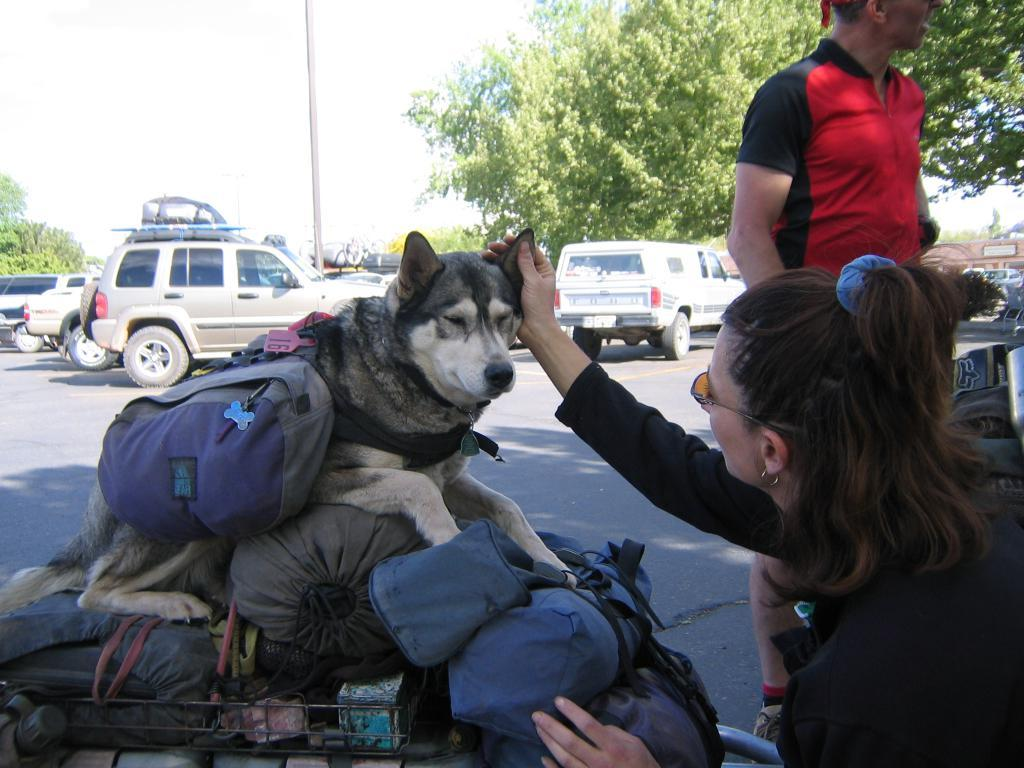What can be seen in the background of the image? There is a sky in the image. What type of natural elements are present in the image? There are trees in the image. What type of man-made objects can be seen in the image? There are cars in the image. How many people are present in the image? There are two people in the image. What type of animal is present in the image? There is a dog in the image. What statement does the porter make about the army in the image? There is no porter or army present in the image, so no such statement can be made. 